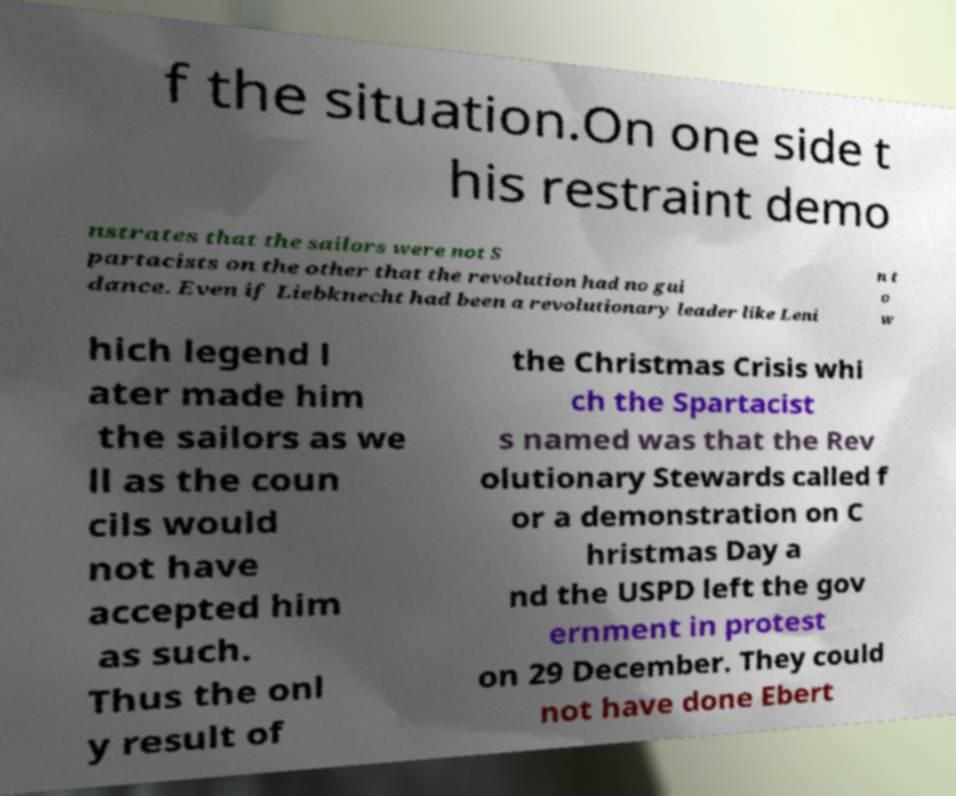Please read and relay the text visible in this image. What does it say? f the situation.On one side t his restraint demo nstrates that the sailors were not S partacists on the other that the revolution had no gui dance. Even if Liebknecht had been a revolutionary leader like Leni n t o w hich legend l ater made him the sailors as we ll as the coun cils would not have accepted him as such. Thus the onl y result of the Christmas Crisis whi ch the Spartacist s named was that the Rev olutionary Stewards called f or a demonstration on C hristmas Day a nd the USPD left the gov ernment in protest on 29 December. They could not have done Ebert 